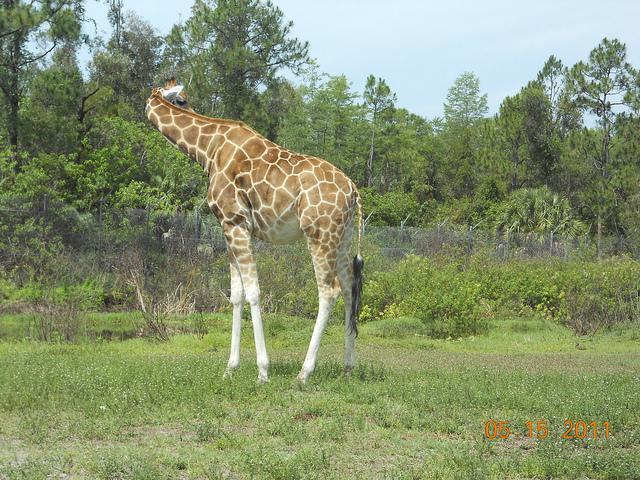How many giraffes are around?
Give a very brief answer. 1. How many animals?
Give a very brief answer. 1. 